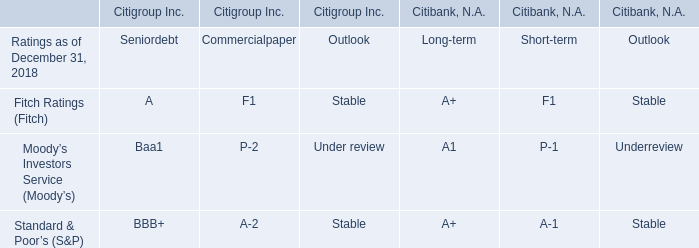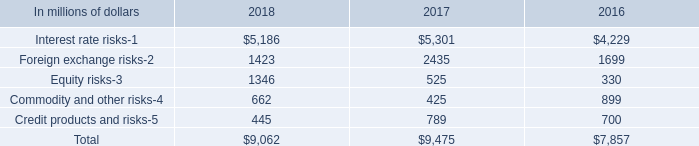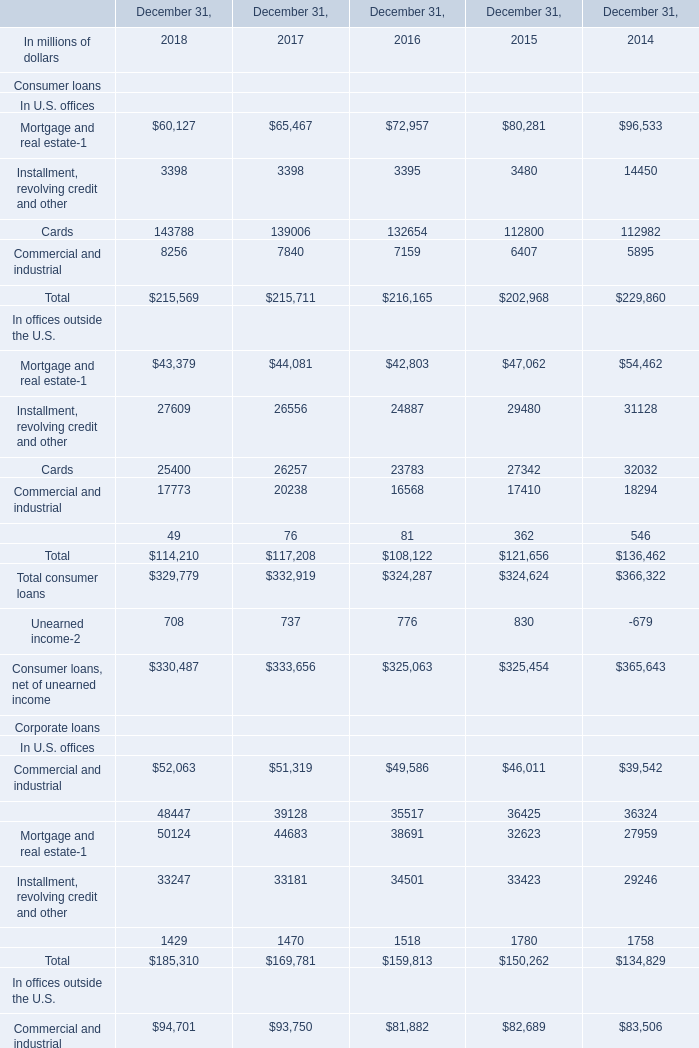What is the total amount of Financial institutions In U.S. offices of December 31, 2016, Foreign exchange risks of 2016, and Financial institutions In U.S. offices of December 31, 2014 ? 
Computations: ((35517.0 + 1699.0) + 36324.0)
Answer: 73540.0. What's the average of Equity risks of 2018, and Commercial and industrial In U.S. offices of December 31, 2015 ? 
Computations: ((1346.0 + 46011.0) / 2)
Answer: 23678.5. 